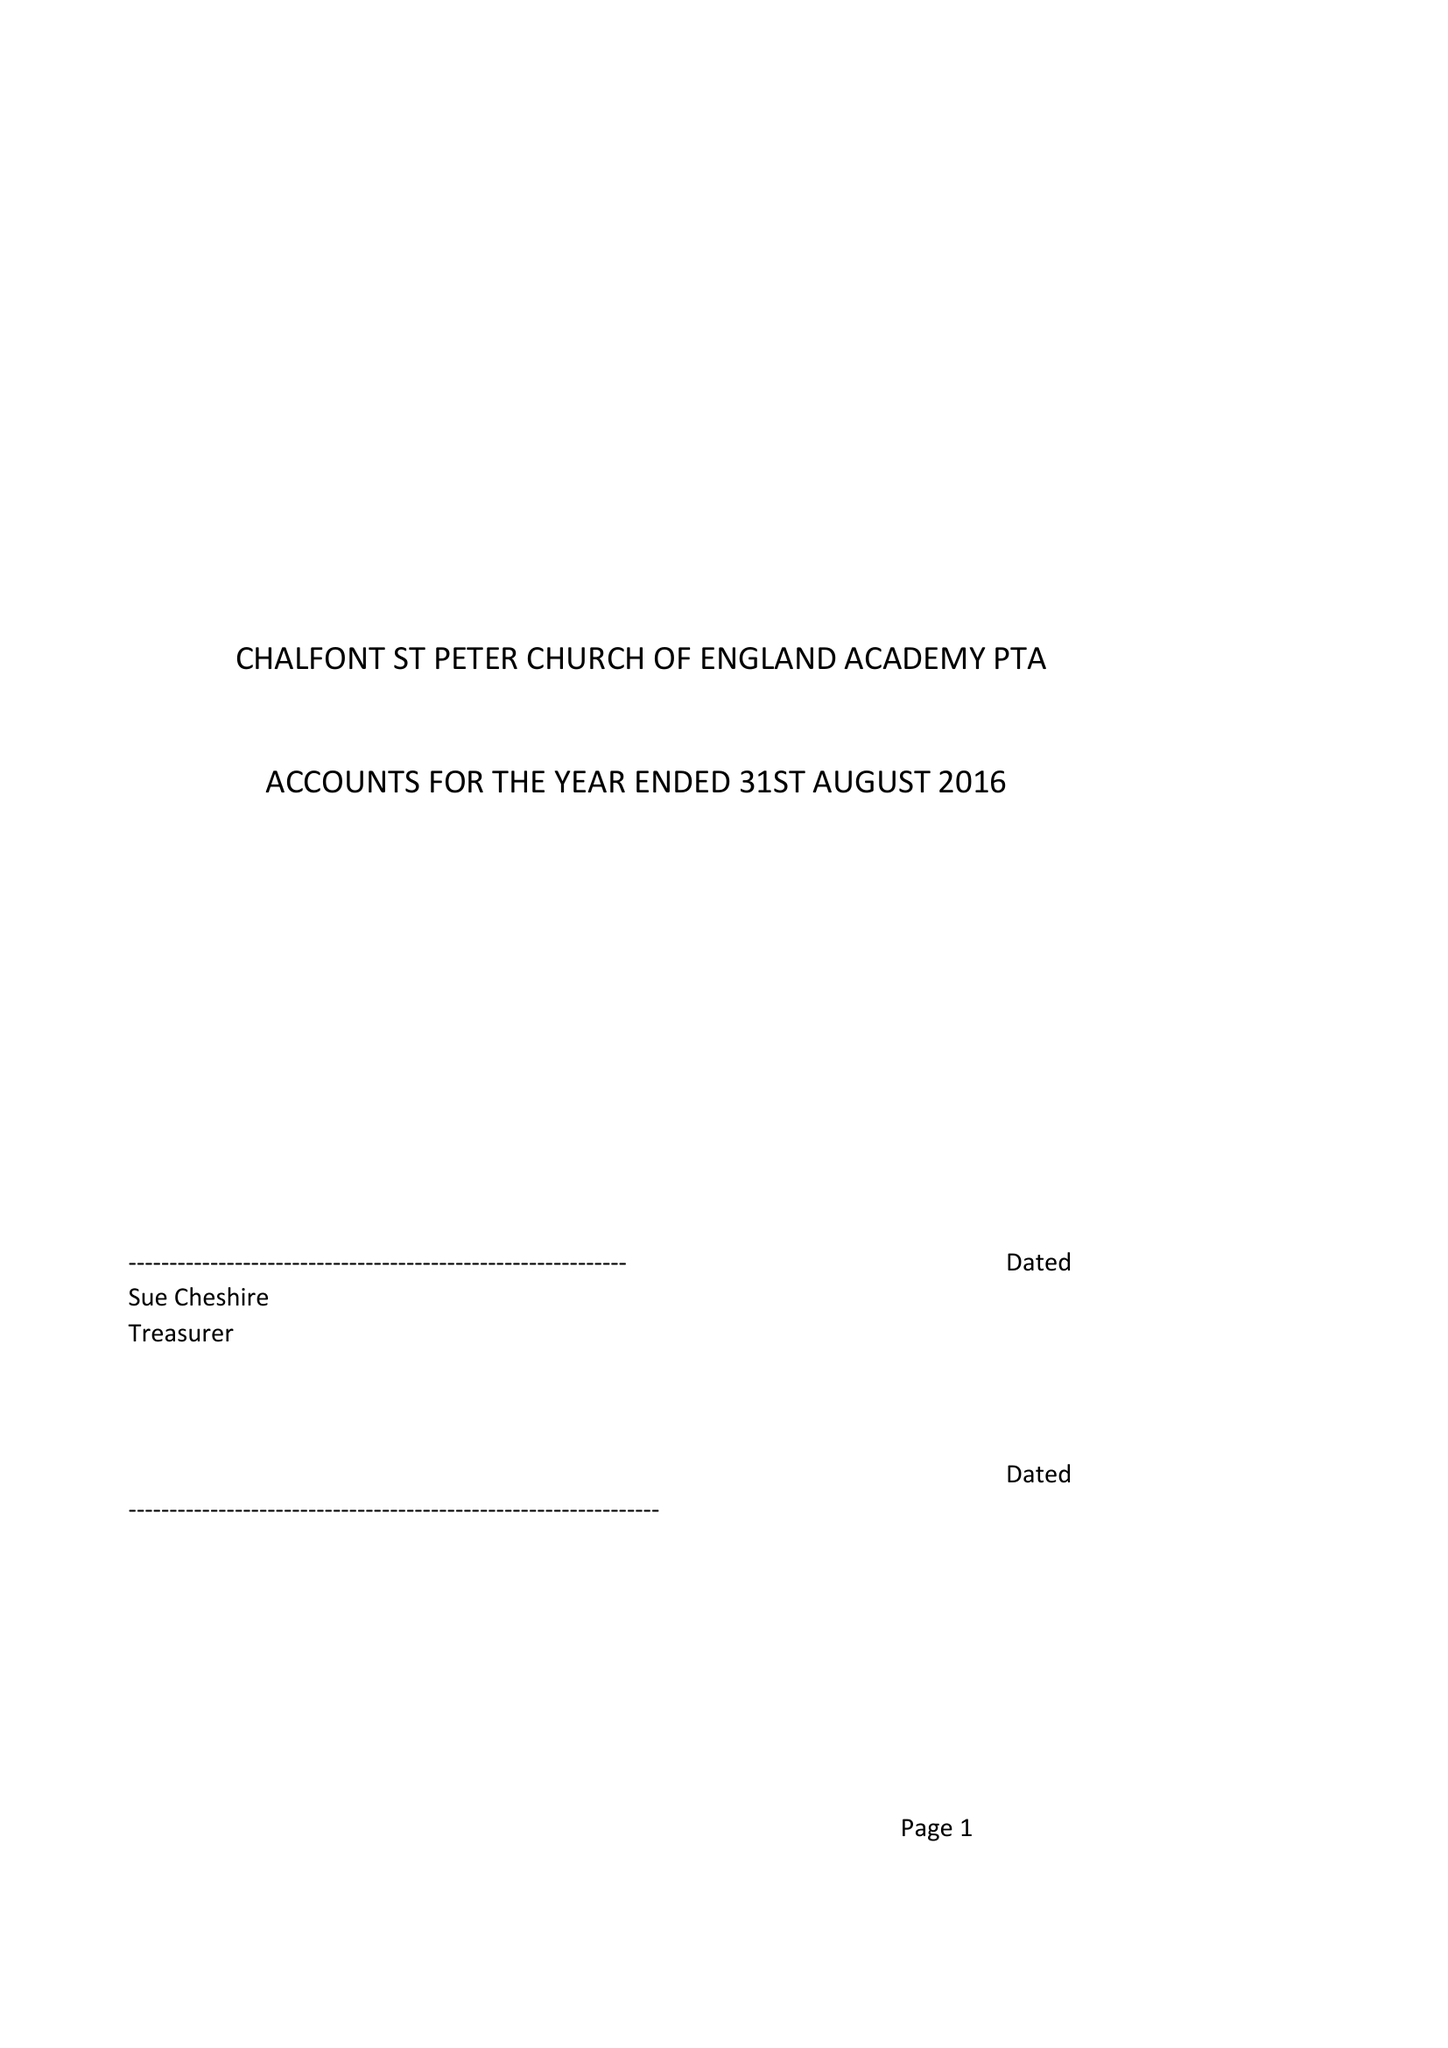What is the value for the address__street_line?
Answer the question using a single word or phrase. PENN ROAD 